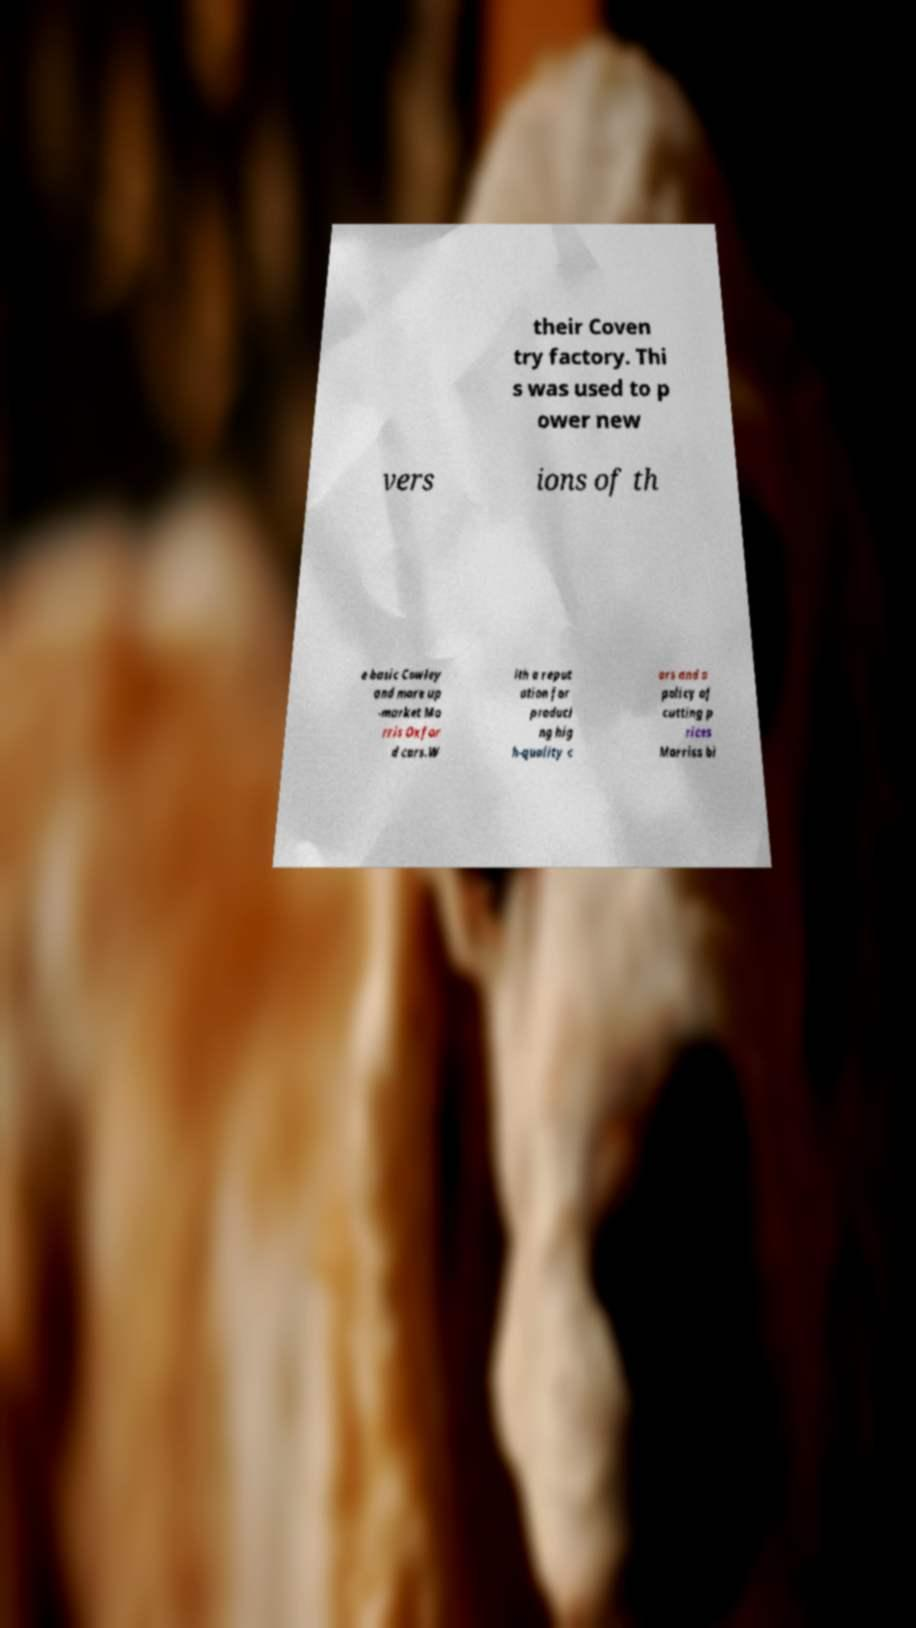I need the written content from this picture converted into text. Can you do that? their Coven try factory. Thi s was used to p ower new vers ions of th e basic Cowley and more up -market Mo rris Oxfor d cars.W ith a reput ation for produci ng hig h-quality c ars and a policy of cutting p rices Morriss bi 